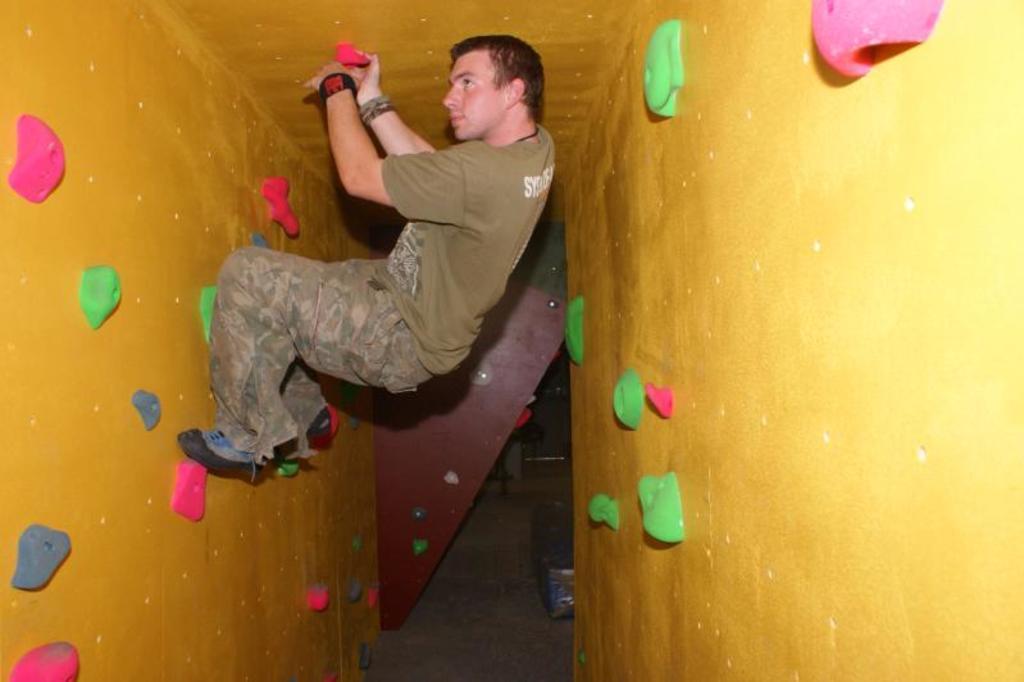Please provide a concise description of this image. In this picture, we see a man is pasting something on the wall. This wall is in yellow color. It looks like the holders. These holders are in green, pink, blue and red color. In the background, we see a brown door. 